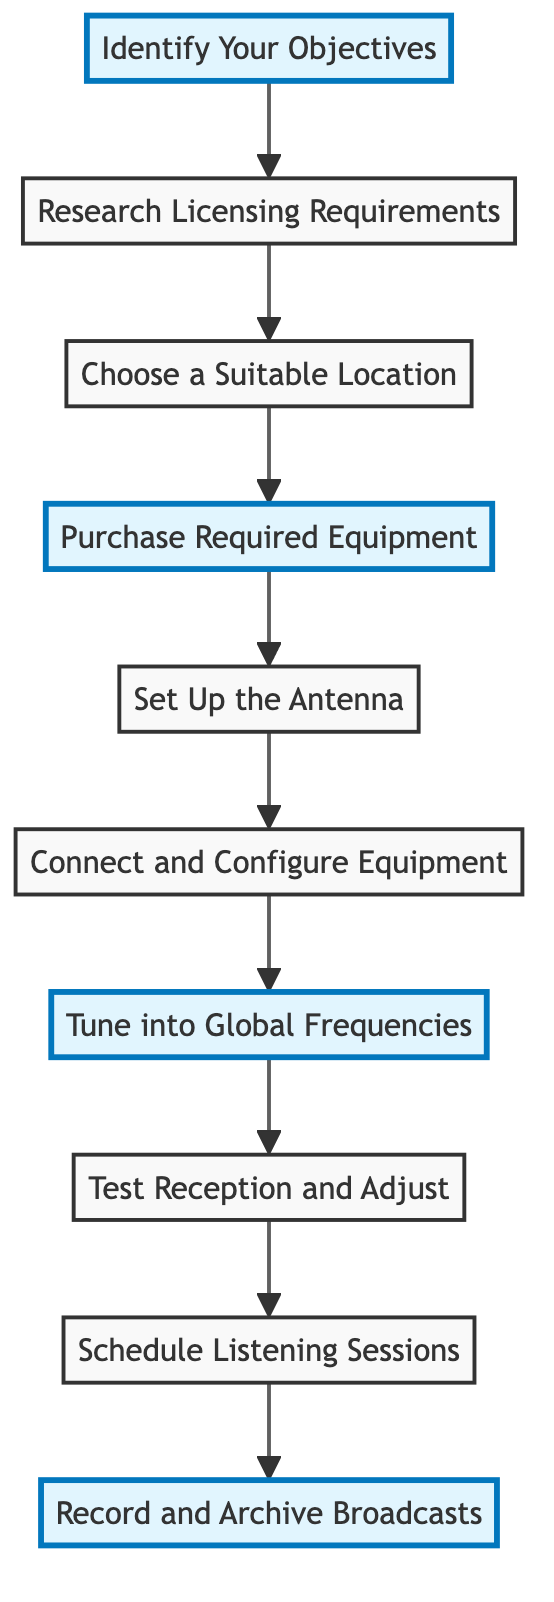What is the first step in setting up a home radio station? The first step is "Identify Your Objectives," which involves determining the global news channels and appropriate listening times.
Answer: Identify Your Objectives How many total steps are there in the flow chart? By counting the elements presented, we find that there are 10 distinct steps listed in the diagram.
Answer: 10 Which node comes immediately after "Purchase Required Equipment"? The node that follows "Purchase Required Equipment" is "Set Up the Antenna," indicating the next action to take after acquiring equipment.
Answer: Set Up the Antenna What is the purpose of "Schedule Listening Sessions"? This step involves creating a plan that aligns with the broadcast times of international news channels, ensuring that listeners are informed.
Answer: Create a schedule What are two highlighted nodes in the flow chart? The highlighted nodes are "Identify Your Objectives," "Purchase Required Equipment," "Tune into Global Frequencies," and "Record and Archive Broadcasts," which signify important stages in the process.
Answer: Identify Your Objectives, Purchase Required Equipment, Tune into Global Frequencies, Record and Archive Broadcasts What action should you take after tuning into global frequencies? The next action after tuning into global frequencies is to "Test Reception and Adjust," which involves testing reception quality and making necessary adjustments.
Answer: Test Reception and Adjust What is the last step according to the diagram? The final step outlined in the flow chart is "Record and Archive Broadcasts," indicating the completion of the setup process for those who wish to keep a record of broadcasts.
Answer: Record and Archive Broadcasts Which steps are necessary before purchasing equipment? Before purchasing equipment, one must first "Identify Your Objectives," "Research Licensing Requirements," and "Choose a Suitable Location," which ensures a proper foundation for the radio station setup.
Answer: Identify Your Objectives, Research Licensing Requirements, Choose a Suitable Location What does the step "Connect and Configure Equipment" entail? This step involves connecting the antenna to the radio receiver, along with configuring the receiver settings for a personalized listening experience, ensuring proper setup before use.
Answer: Connecting and configuring components What resource is suggested for finding global news frequencies? The flow chart recommends using online resources such as "short-wave.info" or the "World Radio TV Handbook" to locate the frequencies of desired international news channels.
Answer: short-wave.info or World Radio TV Handbook 